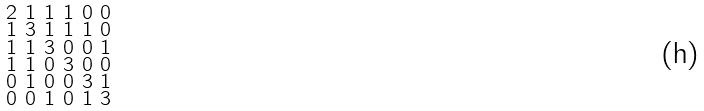<formula> <loc_0><loc_0><loc_500><loc_500>\begin{smallmatrix} 2 & 1 & 1 & 1 & 0 & 0 \\ 1 & 3 & 1 & 1 & 1 & 0 \\ 1 & 1 & 3 & 0 & 0 & 1 \\ 1 & 1 & 0 & 3 & 0 & 0 \\ 0 & 1 & 0 & 0 & 3 & 1 \\ 0 & 0 & 1 & 0 & 1 & 3 \end{smallmatrix}</formula> 